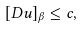<formula> <loc_0><loc_0><loc_500><loc_500>[ D u ] _ { \beta } \leq c ,</formula> 